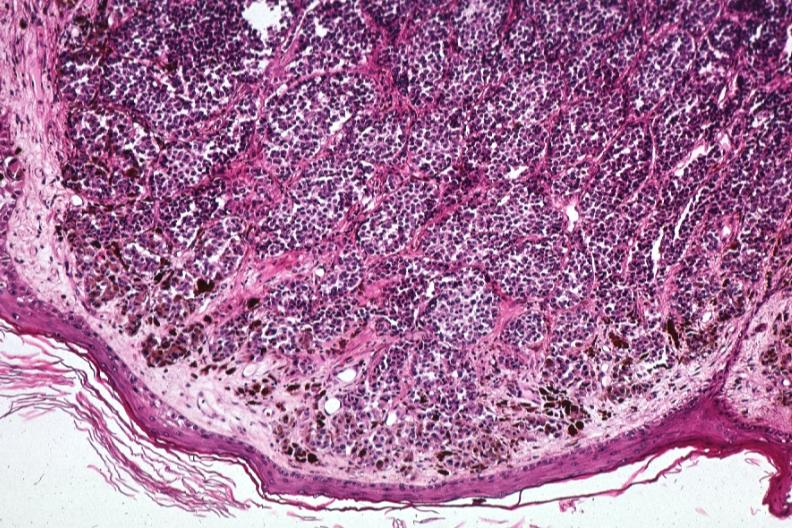what does this image show?
Answer the question using a single word or phrase. Low excellent depiction of lesion that probably is metastatic slides 1 are same lesion 